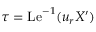<formula> <loc_0><loc_0><loc_500><loc_500>\tau = L e ^ { - 1 } ( u _ { r } X ^ { \prime } )</formula> 